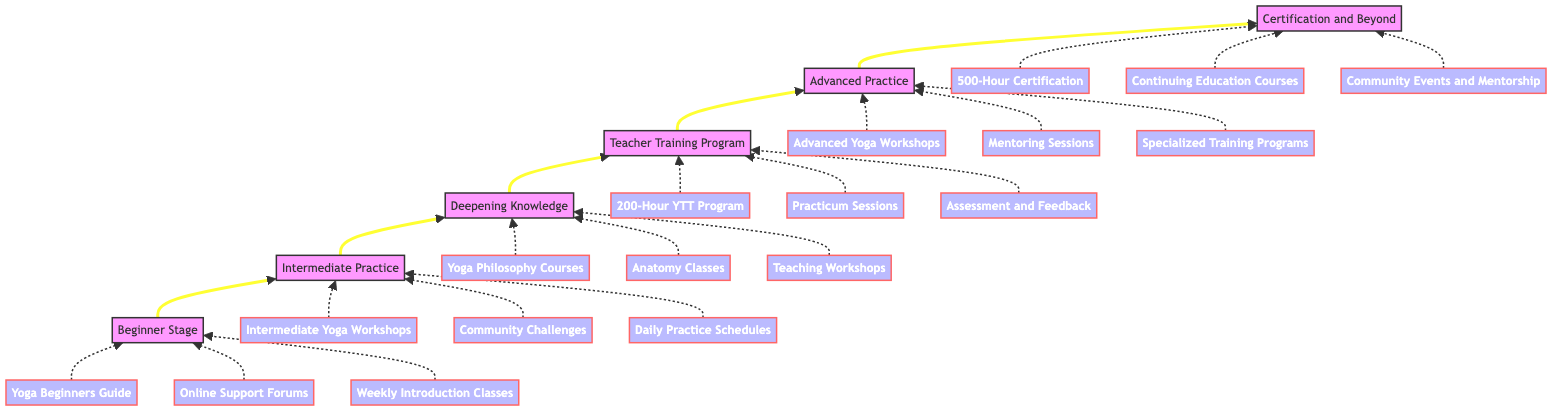What is the first stage in the journey to becoming an advanced yoga instructor? The diagram indicates that the first stage is "Beginner Stage." This is the bottom node in the flow chart, establishing the starting point of the journey.
Answer: Beginner Stage How many total stages are there in the journey from Beginner to Advanced Yoga Instructor? By counting the numbered stages in the flow chart, there are six distinct stages: Beginner Stage, Intermediate Practice, Deepening Knowledge, Teacher Training Program, Advanced Practice, and Certification and Beyond.
Answer: Six What resources are associated with the "Intermediate Practice" stage? "Intermediate Practice" is linked to three resources shown in the diagram: "Intermediate Yoga Workshops," "Community Challenges," and "Daily Practice Schedules." This node's information is derived directly from the connected resource nodes.
Answer: Intermediate Yoga Workshops, Community Challenges, Daily Practice Schedules What two stages are directly connected to "Deepening Knowledge" stage? The stage "Deepening Knowledge" is connected to "Intermediate Practice" (below it) and "Teacher Training Program" (above it) in the upward flow, indicating the sequential relationship between these stages.
Answer: Intermediate Practice, Teacher Training Program What type of program must you enroll in at the "Teacher Training Program" stage? The "Teacher Training Program" stage specifies enrollment in a "200-Hour YTT Program." This is the key certification-related step required to advance in the journey.
Answer: 200-Hour YTT Program Which stage comes immediately after the "Advanced Practice" in the flow chart? Following the upward flow of the diagram, "Certification and Beyond" directly follows "Advanced Practice," indicating the culmination of the training journey.
Answer: Certification and Beyond What is required for certification at the final stage? At the "Certification and Beyond" stage, the requirement is to receive a "500-Hour Certification," which indicates the advanced level of training achieved at the end of the journey.
Answer: 500-Hour Certification What role do mentors play in the "Advanced Practice" stage? The "Advanced Practice" stage indicates that one can attend "Mentoring Sessions," suggesting that mentors provide guidance and support as learners deepen their practice.
Answer: Mentoring Sessions 